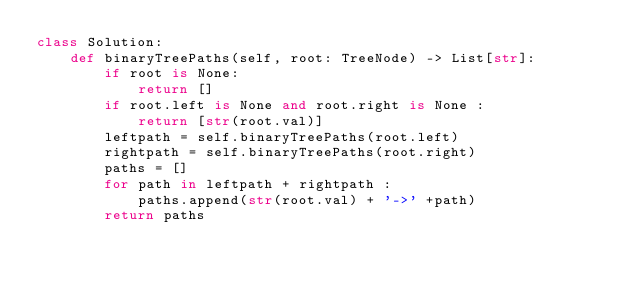Convert code to text. <code><loc_0><loc_0><loc_500><loc_500><_Python_>class Solution:
    def binaryTreePaths(self, root: TreeNode) -> List[str]:
        if root is None:
            return []
        if root.left is None and root.right is None :
            return [str(root.val)]
        leftpath = self.binaryTreePaths(root.left)
        rightpath = self.binaryTreePaths(root.right)
        paths = []
        for path in leftpath + rightpath :
            paths.append(str(root.val) + '->' +path)
        return paths</code> 